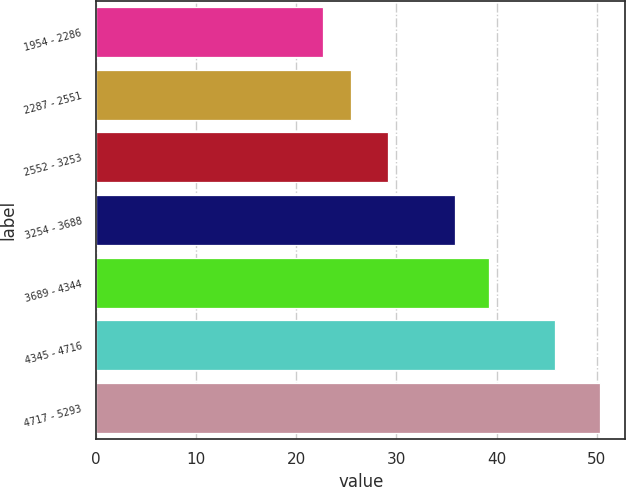Convert chart to OTSL. <chart><loc_0><loc_0><loc_500><loc_500><bar_chart><fcel>1954 - 2286<fcel>2287 - 2551<fcel>2552 - 3253<fcel>3254 - 3688<fcel>3689 - 4344<fcel>4345 - 4716<fcel>4717 - 5293<nl><fcel>22.64<fcel>25.41<fcel>29.15<fcel>35.82<fcel>39.29<fcel>45.81<fcel>50.36<nl></chart> 